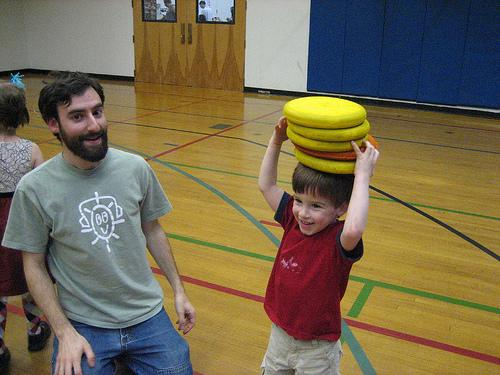Give a creative title for this image that reflects its main subjects and actions. Frisbee Fun Day: Smiling Boy and Bearded Man Share a Cheerful Moment! Detail the interactions between the people and objects in the image. A man with a beard and green shirt is happily interacting with a boy in a red shirt who is skillfully balancing multiple Frisbees on his head. Narrate what might have happened moments before the scene in the image took place. Eager to showcase his skills, the boy with short brown hair piled up several Frisbees onto his head as the bearded man cheered him on. In one sentence, describe the atmosphere and the people in the image. A fun and lively vibe exudes from the bearded man and the boy in red as they enjoy their Frisbee-balancing act in the gym. Mention the most notable feature about the man and the boy in the image. A man with a beard and a boy in a red shirt, both smiling as the boy balances multiple Frisbees on his head. Offer a concise summary of the scene, including the main subjects and their surroundings. In a gymnasium with colorful lines, a bearded man wearing jeans kneels next to a boy in red who's balancing Frisbees on his head. Explain what the subjects of the image are wearing and doing. A man donning a gray shirt and blue jeans, and a boy clad in red, smiling as they play with Frisbees in a gym. Describe the key elements and colors present in the image. A bearded man in gray, a boy in red, yellow Frisbees, wooden doors, and a colorful-floor gymnasium. Write a brief caption describing the emotions conveyed by the people in the image. Happy bearded man in jeans and a joyous boy balancing Frisbees create a delightful gym scene. Provide a short description of the primary activity or moment captured in the image. A man is kneeling beside a smiling boy who is skillfully balancing several Frisbees on top of his head.  